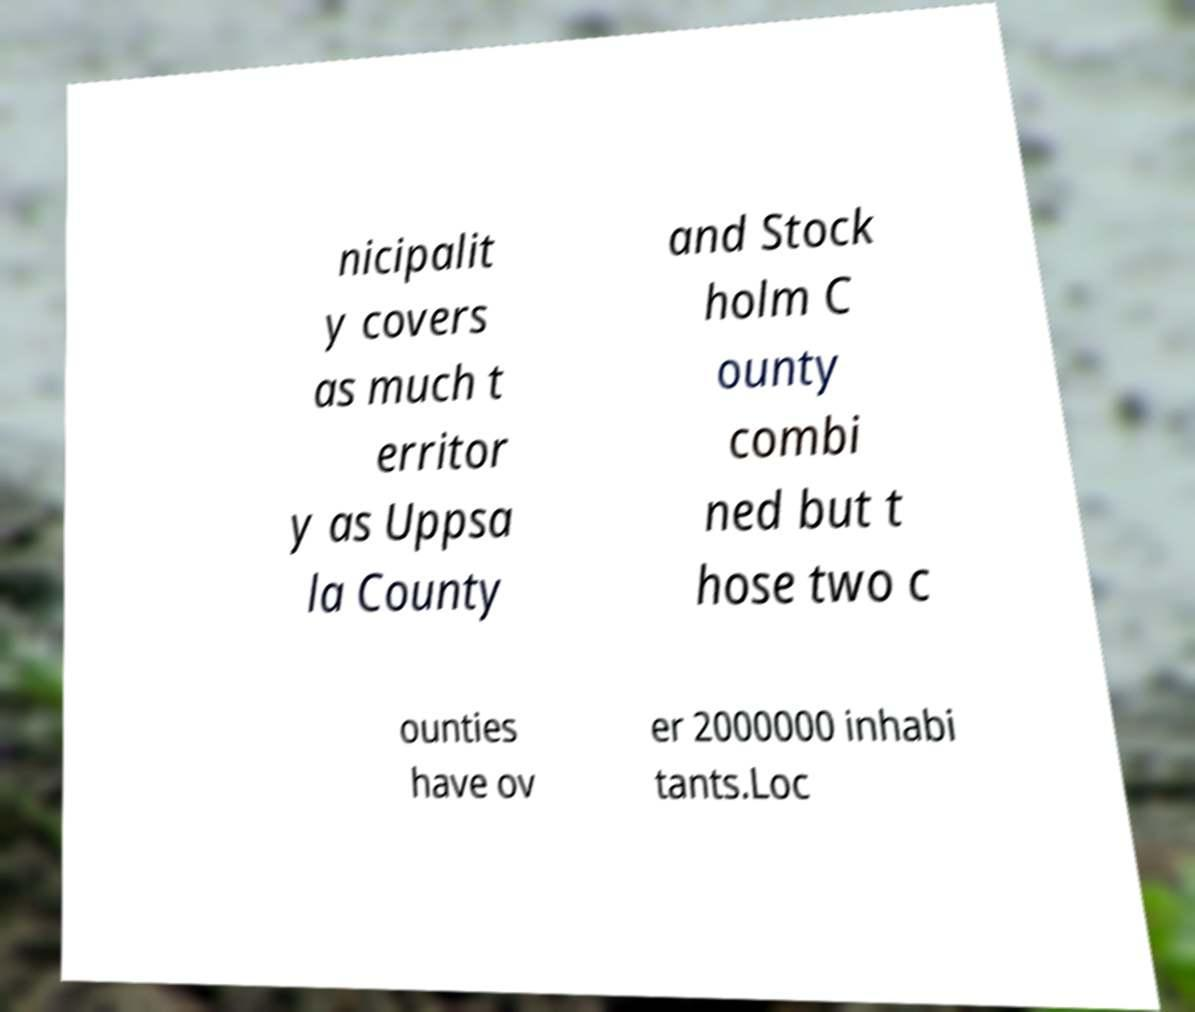There's text embedded in this image that I need extracted. Can you transcribe it verbatim? nicipalit y covers as much t erritor y as Uppsa la County and Stock holm C ounty combi ned but t hose two c ounties have ov er 2000000 inhabi tants.Loc 